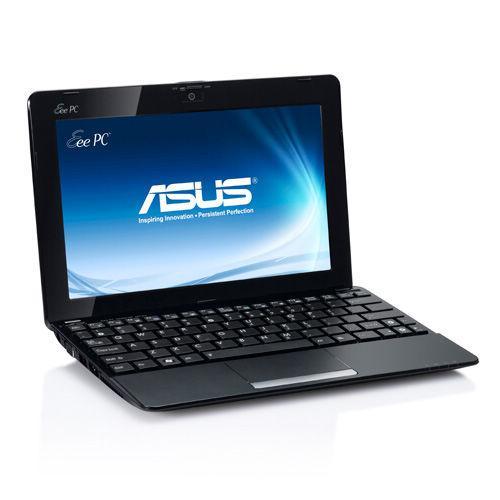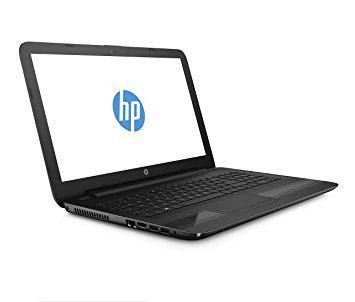The first image is the image on the left, the second image is the image on the right. Considering the images on both sides, is "The laptop in the image on the left is facing right." valid? Answer yes or no. Yes. 